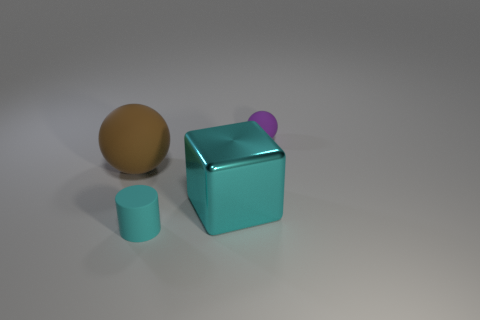Are there any small things that have the same material as the big brown object?
Provide a short and direct response. Yes. What is the material of the sphere that is the same size as the rubber cylinder?
Provide a succinct answer. Rubber. There is a matte ball that is on the left side of the cyan rubber thing; is it the same color as the small matte object that is right of the small matte cylinder?
Offer a very short reply. No. There is a small object in front of the cube; are there any rubber things right of it?
Your response must be concise. Yes. There is a tiny object right of the large cyan block; is it the same shape as the large brown rubber object behind the small cylinder?
Ensure brevity in your answer.  Yes. Are the small thing that is on the left side of the big cyan metallic block and the sphere that is in front of the purple sphere made of the same material?
Provide a succinct answer. Yes. What is the small object that is behind the cyan object in front of the big cyan thing made of?
Keep it short and to the point. Rubber. There is a small rubber object to the left of the tiny matte thing that is behind the matte ball in front of the purple ball; what shape is it?
Your response must be concise. Cylinder. There is a small object that is the same shape as the large matte object; what material is it?
Offer a very short reply. Rubber. How many large red shiny things are there?
Offer a very short reply. 0. 